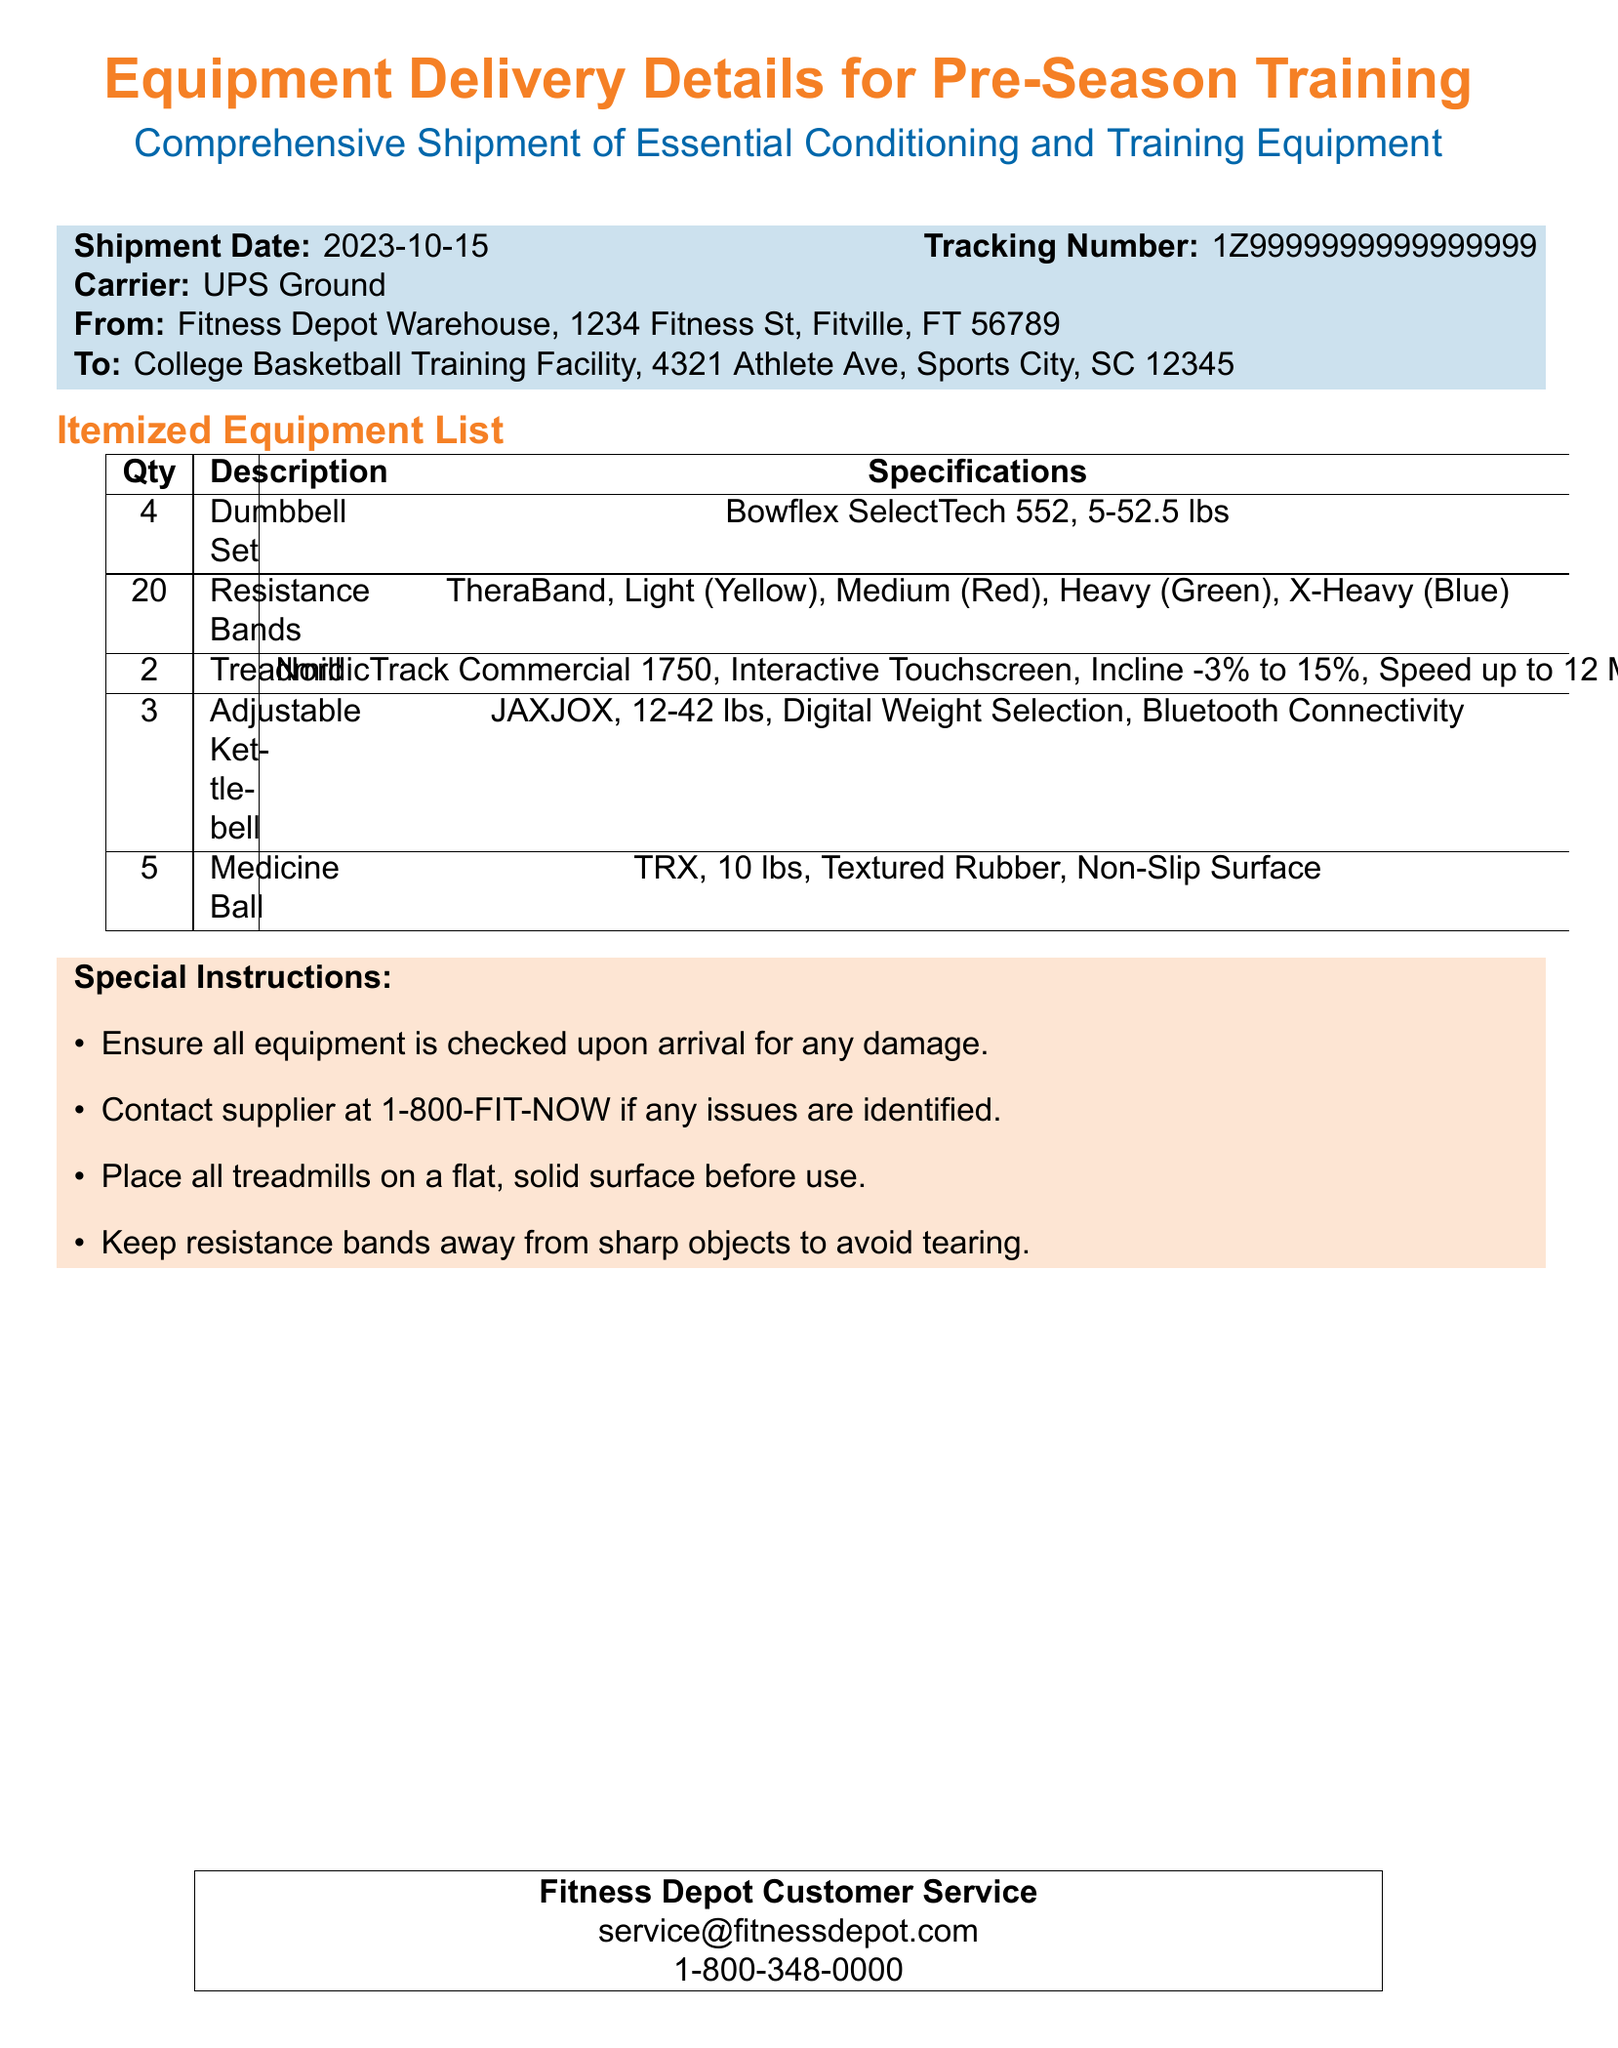what is the shipment date? The shipment date is stated prominently in the document for quick reference.
Answer: 2023-10-15 who is the carrier? This information is included to identify the company responsible for delivering the equipment.
Answer: UPS Ground how many dumbbell sets are included? The quantity of dumbbell sets is specified in the itemized equipment list.
Answer: 4 what should you do if there is any damage to the equipment? This instruction is provided to ensure the handling of potential issues upon arrival.
Answer: Contact supplier what type of treadmill is delivered? The description of the treadmill is specified in the itemized equipment list.
Answer: NordicTrack Commercial 1750 how many different resistance band types are mentioned? The document lists multiple resistance band types under the itemized equipment section.
Answer: 4 what is the customer service phone number? This number is provided for inquiries or assistance related to the order.
Answer: 1-800-348-0000 where is the shipment being sent? The destination address is provided for clarity on where the equipment is going.
Answer: College Basketball Training Facility, Sports City what is the total quantity of medicine balls? The total number of medicine balls listed in the equipment section is crucial for understanding shipment volume.
Answer: 5 